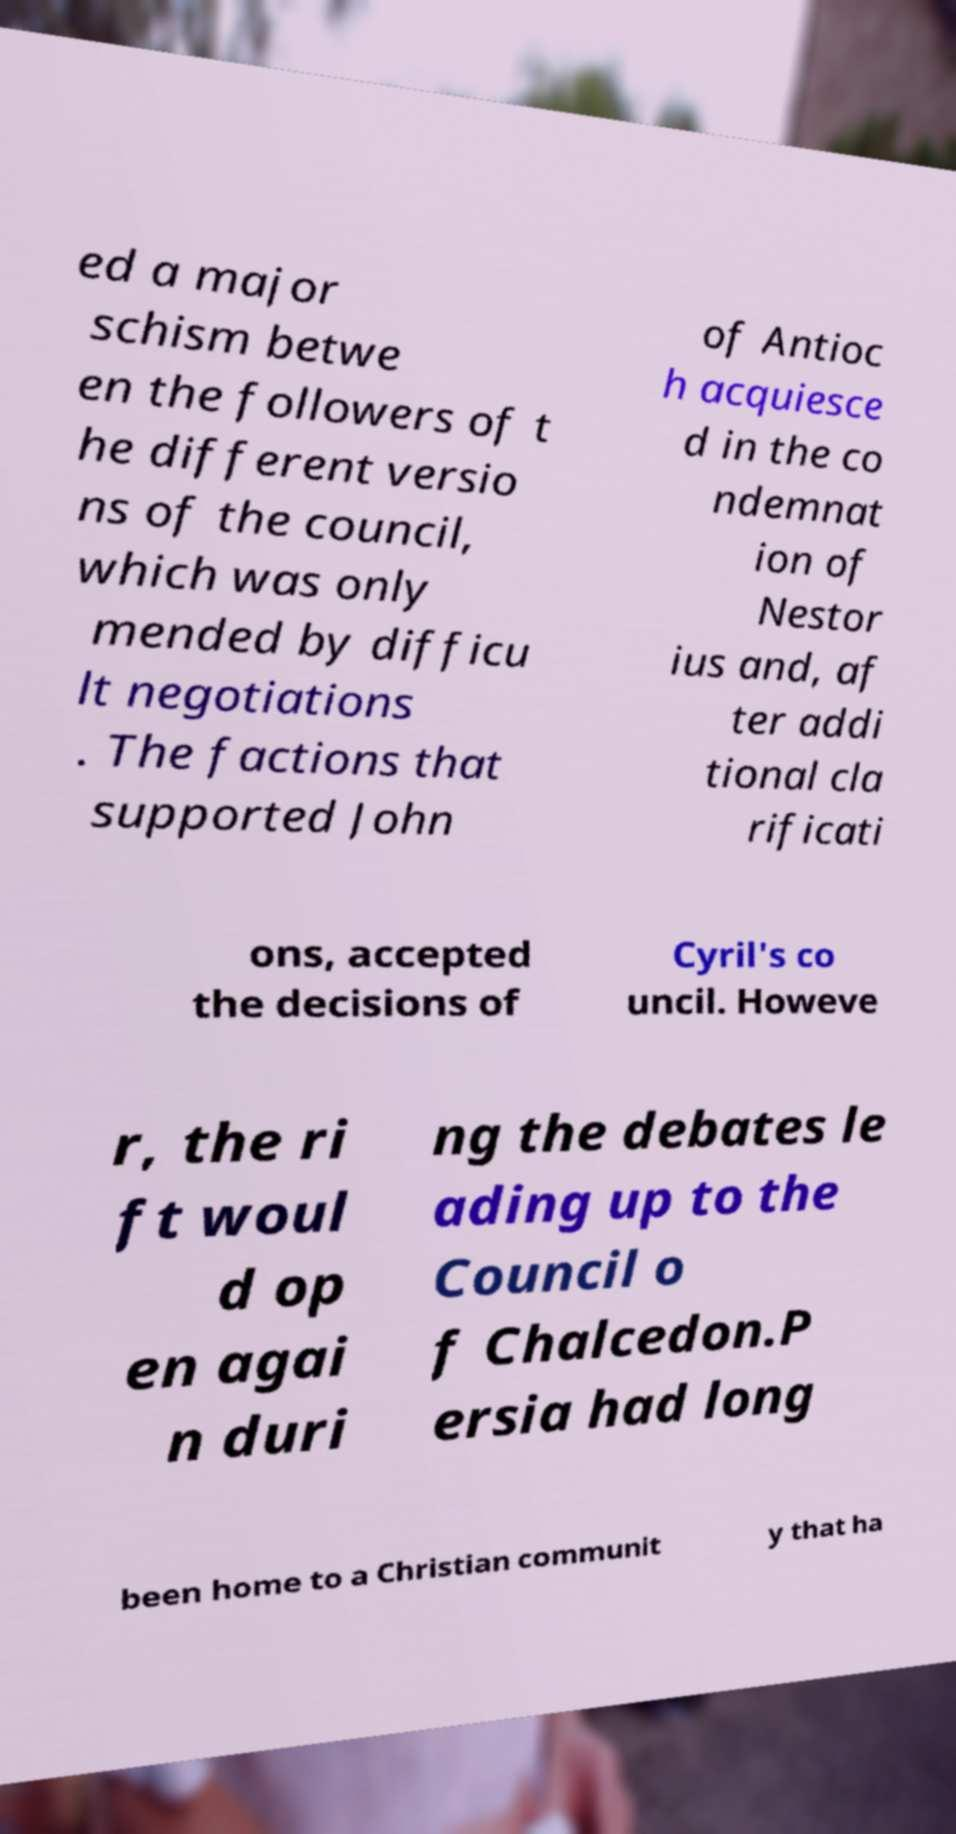Could you extract and type out the text from this image? ed a major schism betwe en the followers of t he different versio ns of the council, which was only mended by difficu lt negotiations . The factions that supported John of Antioc h acquiesce d in the co ndemnat ion of Nestor ius and, af ter addi tional cla rificati ons, accepted the decisions of Cyril's co uncil. Howeve r, the ri ft woul d op en agai n duri ng the debates le ading up to the Council o f Chalcedon.P ersia had long been home to a Christian communit y that ha 